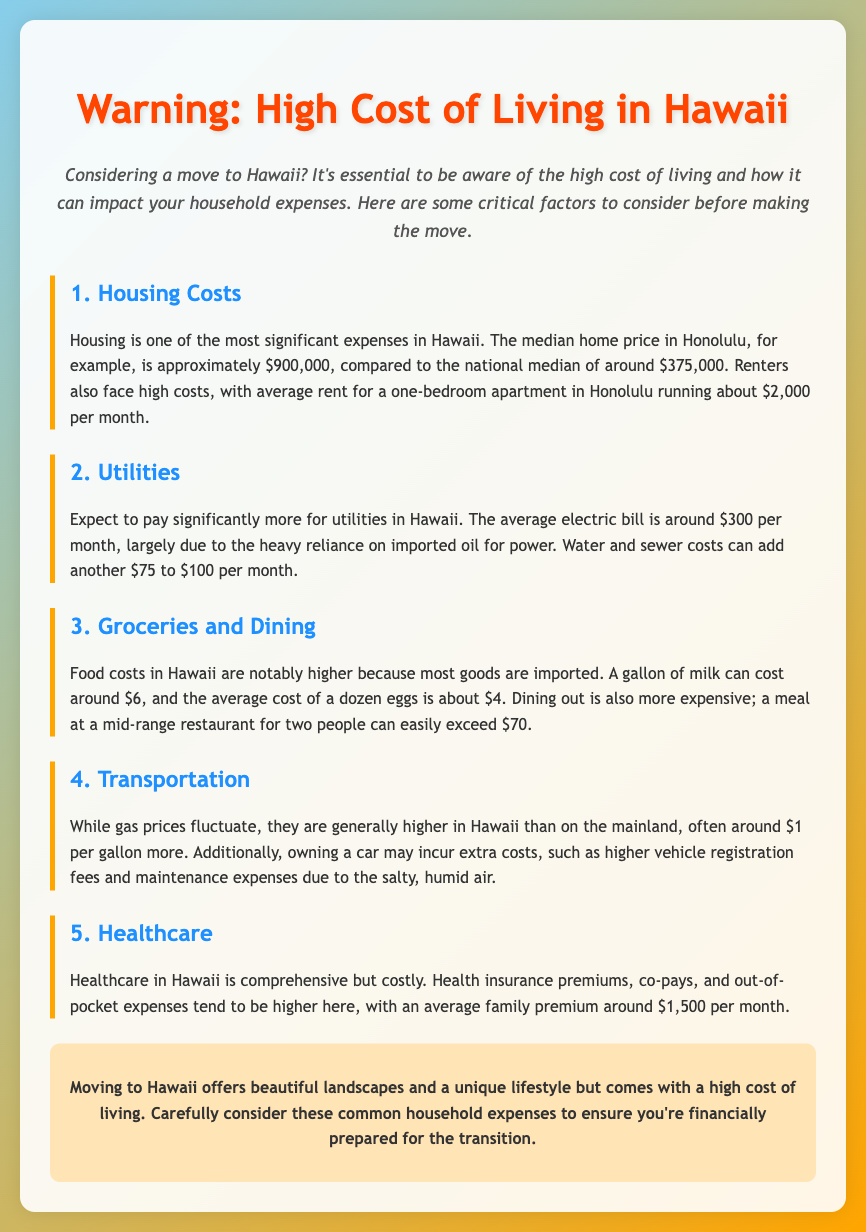What is the median home price in Honolulu? The document states that the median home price in Honolulu is approximately $900,000.
Answer: $900,000 What is the average rent for a one-bedroom apartment in Honolulu? According to the document, the average rent for a one-bedroom apartment in Honolulu is about $2,000 per month.
Answer: $2,000 How much does the average electric bill cost per month? The average electric bill in Hawaii is around $300 per month, as mentioned in the document.
Answer: $300 What is the average cost of a dozen eggs in Hawaii? The document mentions that the average cost of a dozen eggs is about $4.
Answer: $4 What is the average family health insurance premium in Hawaii? The average family health insurance premium in Hawaii is around $1,500 per month, as stated in the document.
Answer: $1,500 Why are housing costs in Hawaii higher than the national average? Housing costs are higher due to the high median home price and rental rates mentioned in the document.
Answer: High median home price and rental rates What additional expenses should new residents expect regarding utilities? New residents should expect additional expenses of $75 to $100 per month for water and sewer costs.
Answer: $75 to $100 What is the general trend in gas prices in Hawaii compared to the mainland? Gas prices in Hawaii are generally around $1 per gallon more than on the mainland, as stated in the document.
Answer: Around $1 more What is the key takeaway from the conclusion in the document? The key takeaway from the conclusion is that moving to Hawaii comes with a high cost of living that requires careful financial consideration.
Answer: High cost of living requires financial consideration 